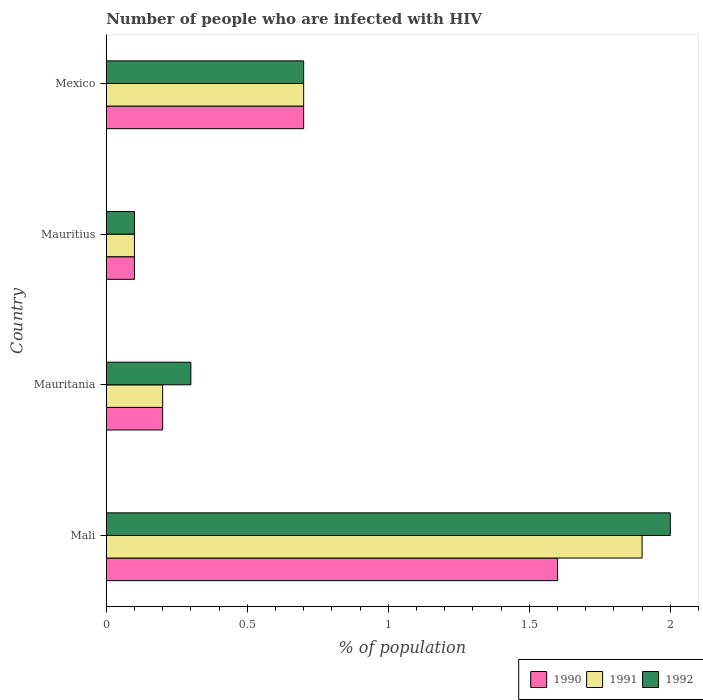How many groups of bars are there?
Offer a very short reply. 4. Are the number of bars per tick equal to the number of legend labels?
Your answer should be compact. Yes. Are the number of bars on each tick of the Y-axis equal?
Provide a short and direct response. Yes. How many bars are there on the 3rd tick from the top?
Make the answer very short. 3. How many bars are there on the 3rd tick from the bottom?
Your answer should be compact. 3. What is the label of the 4th group of bars from the top?
Ensure brevity in your answer.  Mali. In how many cases, is the number of bars for a given country not equal to the number of legend labels?
Make the answer very short. 0. What is the percentage of HIV infected population in in 1990 in Mexico?
Your answer should be compact. 0.7. Across all countries, what is the maximum percentage of HIV infected population in in 1991?
Keep it short and to the point. 1.9. Across all countries, what is the minimum percentage of HIV infected population in in 1991?
Your answer should be very brief. 0.1. In which country was the percentage of HIV infected population in in 1992 maximum?
Give a very brief answer. Mali. In which country was the percentage of HIV infected population in in 1992 minimum?
Make the answer very short. Mauritius. What is the total percentage of HIV infected population in in 1992 in the graph?
Make the answer very short. 3.1. What is the difference between the percentage of HIV infected population in in 1992 in Mali and that in Mauritius?
Provide a succinct answer. 1.9. What is the difference between the percentage of HIV infected population in in 1990 in Mauritania and the percentage of HIV infected population in in 1992 in Mexico?
Ensure brevity in your answer.  -0.5. What is the average percentage of HIV infected population in in 1990 per country?
Give a very brief answer. 0.65. What is the difference between the percentage of HIV infected population in in 1992 and percentage of HIV infected population in in 1991 in Mauritania?
Make the answer very short. 0.1. What is the ratio of the percentage of HIV infected population in in 1991 in Mauritius to that in Mexico?
Offer a terse response. 0.14. Is the percentage of HIV infected population in in 1992 in Mauritania less than that in Mauritius?
Your answer should be compact. No. Is the difference between the percentage of HIV infected population in in 1992 in Mauritius and Mexico greater than the difference between the percentage of HIV infected population in in 1991 in Mauritius and Mexico?
Ensure brevity in your answer.  No. How many bars are there?
Keep it short and to the point. 12. Are the values on the major ticks of X-axis written in scientific E-notation?
Offer a very short reply. No. Does the graph contain any zero values?
Your answer should be very brief. No. Does the graph contain grids?
Keep it short and to the point. No. How are the legend labels stacked?
Give a very brief answer. Horizontal. What is the title of the graph?
Provide a short and direct response. Number of people who are infected with HIV. Does "1993" appear as one of the legend labels in the graph?
Your answer should be very brief. No. What is the label or title of the X-axis?
Give a very brief answer. % of population. What is the % of population in 1990 in Mali?
Keep it short and to the point. 1.6. What is the % of population of 1991 in Mali?
Give a very brief answer. 1.9. What is the % of population of 1990 in Mauritania?
Offer a terse response. 0.2. What is the % of population in 1992 in Mauritania?
Provide a short and direct response. 0.3. What is the % of population in 1991 in Mauritius?
Your response must be concise. 0.1. What is the % of population of 1992 in Mauritius?
Your response must be concise. 0.1. What is the % of population in 1990 in Mexico?
Ensure brevity in your answer.  0.7. What is the % of population of 1991 in Mexico?
Give a very brief answer. 0.7. Across all countries, what is the maximum % of population in 1990?
Your answer should be compact. 1.6. Across all countries, what is the maximum % of population of 1991?
Your answer should be very brief. 1.9. Across all countries, what is the maximum % of population in 1992?
Your answer should be compact. 2. Across all countries, what is the minimum % of population in 1990?
Make the answer very short. 0.1. Across all countries, what is the minimum % of population in 1992?
Your answer should be very brief. 0.1. What is the total % of population in 1990 in the graph?
Make the answer very short. 2.6. What is the total % of population in 1991 in the graph?
Give a very brief answer. 2.9. What is the total % of population in 1992 in the graph?
Give a very brief answer. 3.1. What is the difference between the % of population in 1990 in Mali and that in Mauritania?
Give a very brief answer. 1.4. What is the difference between the % of population of 1991 in Mali and that in Mauritania?
Offer a very short reply. 1.7. What is the difference between the % of population in 1990 in Mali and that in Mauritius?
Your response must be concise. 1.5. What is the difference between the % of population in 1990 in Mali and that in Mexico?
Make the answer very short. 0.9. What is the difference between the % of population in 1991 in Mali and that in Mexico?
Provide a succinct answer. 1.2. What is the difference between the % of population of 1992 in Mali and that in Mexico?
Provide a short and direct response. 1.3. What is the difference between the % of population of 1990 in Mauritania and that in Mauritius?
Keep it short and to the point. 0.1. What is the difference between the % of population of 1990 in Mauritania and that in Mexico?
Offer a terse response. -0.5. What is the difference between the % of population in 1991 in Mauritania and that in Mexico?
Make the answer very short. -0.5. What is the difference between the % of population in 1992 in Mauritania and that in Mexico?
Give a very brief answer. -0.4. What is the difference between the % of population in 1990 in Mauritius and that in Mexico?
Ensure brevity in your answer.  -0.6. What is the difference between the % of population of 1992 in Mauritius and that in Mexico?
Offer a terse response. -0.6. What is the difference between the % of population in 1991 in Mali and the % of population in 1992 in Mauritania?
Your answer should be compact. 1.6. What is the difference between the % of population in 1990 in Mali and the % of population in 1992 in Mauritius?
Make the answer very short. 1.5. What is the difference between the % of population in 1991 in Mali and the % of population in 1992 in Mauritius?
Keep it short and to the point. 1.8. What is the difference between the % of population in 1990 in Mali and the % of population in 1991 in Mexico?
Provide a succinct answer. 0.9. What is the difference between the % of population of 1990 in Mali and the % of population of 1992 in Mexico?
Ensure brevity in your answer.  0.9. What is the difference between the % of population in 1991 in Mali and the % of population in 1992 in Mexico?
Your answer should be very brief. 1.2. What is the difference between the % of population in 1990 in Mauritania and the % of population in 1992 in Mauritius?
Provide a short and direct response. 0.1. What is the difference between the % of population of 1991 in Mauritania and the % of population of 1992 in Mauritius?
Provide a short and direct response. 0.1. What is the difference between the % of population in 1990 in Mauritania and the % of population in 1992 in Mexico?
Provide a short and direct response. -0.5. What is the difference between the % of population in 1990 in Mauritius and the % of population in 1991 in Mexico?
Your answer should be very brief. -0.6. What is the difference between the % of population in 1990 in Mauritius and the % of population in 1992 in Mexico?
Your answer should be compact. -0.6. What is the average % of population of 1990 per country?
Offer a very short reply. 0.65. What is the average % of population in 1991 per country?
Your answer should be compact. 0.72. What is the average % of population in 1992 per country?
Ensure brevity in your answer.  0.78. What is the difference between the % of population in 1990 and % of population in 1992 in Mali?
Your answer should be compact. -0.4. What is the difference between the % of population in 1991 and % of population in 1992 in Mali?
Offer a very short reply. -0.1. What is the difference between the % of population in 1991 and % of population in 1992 in Mauritania?
Offer a very short reply. -0.1. What is the difference between the % of population in 1991 and % of population in 1992 in Mauritius?
Make the answer very short. 0. What is the difference between the % of population of 1990 and % of population of 1992 in Mexico?
Your answer should be very brief. 0. What is the difference between the % of population of 1991 and % of population of 1992 in Mexico?
Keep it short and to the point. 0. What is the ratio of the % of population of 1992 in Mali to that in Mauritania?
Make the answer very short. 6.67. What is the ratio of the % of population of 1991 in Mali to that in Mauritius?
Offer a terse response. 19. What is the ratio of the % of population of 1992 in Mali to that in Mauritius?
Provide a short and direct response. 20. What is the ratio of the % of population in 1990 in Mali to that in Mexico?
Provide a short and direct response. 2.29. What is the ratio of the % of population of 1991 in Mali to that in Mexico?
Keep it short and to the point. 2.71. What is the ratio of the % of population of 1992 in Mali to that in Mexico?
Keep it short and to the point. 2.86. What is the ratio of the % of population of 1990 in Mauritania to that in Mauritius?
Offer a very short reply. 2. What is the ratio of the % of population in 1992 in Mauritania to that in Mauritius?
Give a very brief answer. 3. What is the ratio of the % of population of 1990 in Mauritania to that in Mexico?
Offer a very short reply. 0.29. What is the ratio of the % of population in 1991 in Mauritania to that in Mexico?
Your answer should be very brief. 0.29. What is the ratio of the % of population of 1992 in Mauritania to that in Mexico?
Offer a very short reply. 0.43. What is the ratio of the % of population of 1990 in Mauritius to that in Mexico?
Provide a succinct answer. 0.14. What is the ratio of the % of population in 1991 in Mauritius to that in Mexico?
Your response must be concise. 0.14. What is the ratio of the % of population of 1992 in Mauritius to that in Mexico?
Give a very brief answer. 0.14. What is the difference between the highest and the second highest % of population of 1990?
Your response must be concise. 0.9. What is the difference between the highest and the second highest % of population in 1991?
Provide a succinct answer. 1.2. What is the difference between the highest and the lowest % of population in 1991?
Provide a short and direct response. 1.8. What is the difference between the highest and the lowest % of population in 1992?
Your response must be concise. 1.9. 